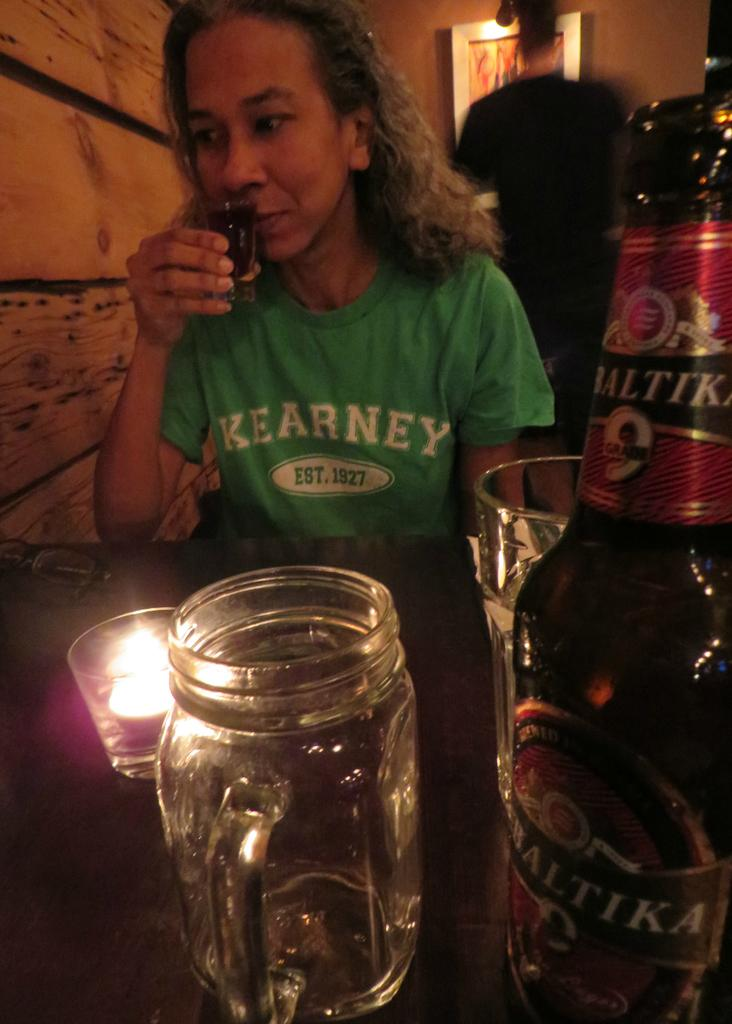<image>
Give a short and clear explanation of the subsequent image. A woman wearing a green Kearney shirt is looking to drink a shot of beer. 